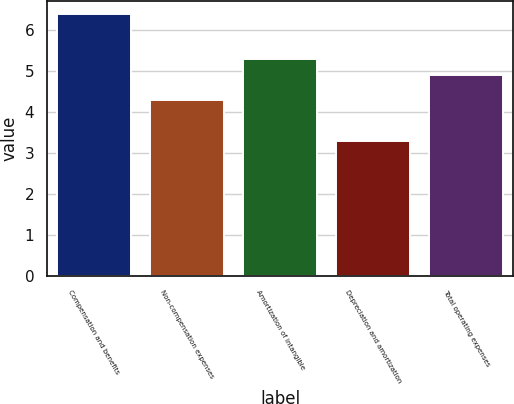Convert chart. <chart><loc_0><loc_0><loc_500><loc_500><bar_chart><fcel>Compensation and benefits<fcel>Non-compensation expenses<fcel>Amortization of intangible<fcel>Depreciation and amortization<fcel>Total operating expenses<nl><fcel>6.4<fcel>4.3<fcel>5.3<fcel>3.3<fcel>4.9<nl></chart> 